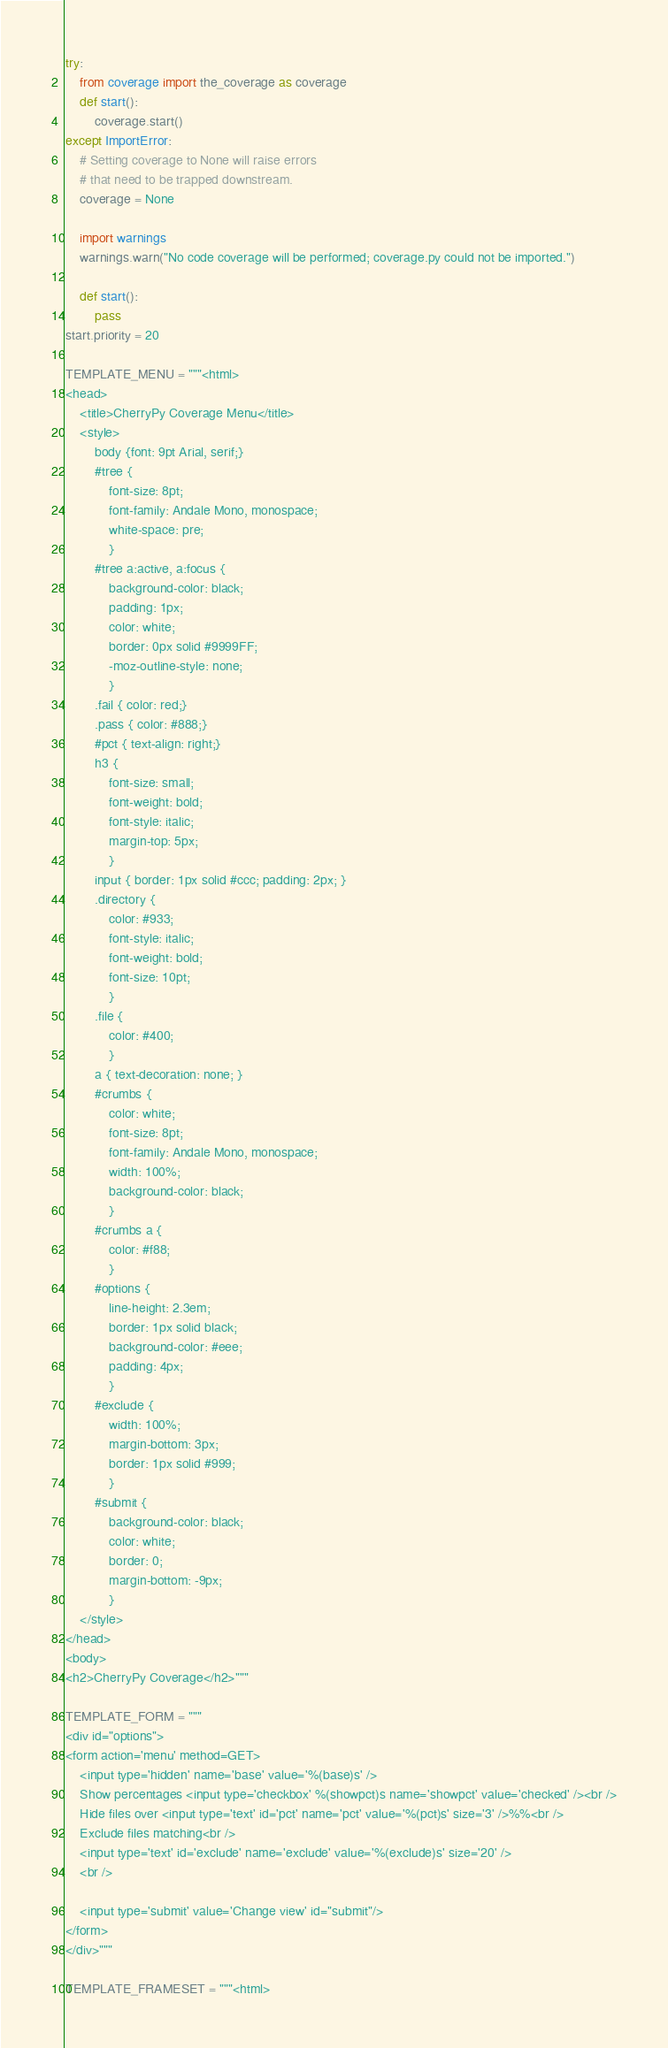Convert code to text. <code><loc_0><loc_0><loc_500><loc_500><_Python_>
try:
    from coverage import the_coverage as coverage
    def start():
        coverage.start()
except ImportError:
    # Setting coverage to None will raise errors
    # that need to be trapped downstream.
    coverage = None
    
    import warnings
    warnings.warn("No code coverage will be performed; coverage.py could not be imported.")
    
    def start():
        pass
start.priority = 20

TEMPLATE_MENU = """<html>
<head>
    <title>CherryPy Coverage Menu</title>
    <style>
        body {font: 9pt Arial, serif;}
        #tree {
            font-size: 8pt;
            font-family: Andale Mono, monospace;
            white-space: pre;
            }
        #tree a:active, a:focus {
            background-color: black;
            padding: 1px;
            color: white;
            border: 0px solid #9999FF;
            -moz-outline-style: none;
            }
        .fail { color: red;}
        .pass { color: #888;}
        #pct { text-align: right;}
        h3 {
            font-size: small;
            font-weight: bold;
            font-style: italic;
            margin-top: 5px; 
            }
        input { border: 1px solid #ccc; padding: 2px; }
        .directory {
            color: #933;
            font-style: italic;
            font-weight: bold;
            font-size: 10pt;
            }
        .file {
            color: #400;
            }
        a { text-decoration: none; }
        #crumbs {
            color: white;
            font-size: 8pt;
            font-family: Andale Mono, monospace;
            width: 100%;
            background-color: black;
            }
        #crumbs a {
            color: #f88;
            }
        #options {
            line-height: 2.3em;
            border: 1px solid black;
            background-color: #eee;
            padding: 4px;
            }
        #exclude {
            width: 100%;
            margin-bottom: 3px;
            border: 1px solid #999;
            }
        #submit {
            background-color: black;
            color: white;
            border: 0;
            margin-bottom: -9px;
            }
    </style>
</head>
<body>
<h2>CherryPy Coverage</h2>"""

TEMPLATE_FORM = """
<div id="options">
<form action='menu' method=GET>
    <input type='hidden' name='base' value='%(base)s' />
    Show percentages <input type='checkbox' %(showpct)s name='showpct' value='checked' /><br />
    Hide files over <input type='text' id='pct' name='pct' value='%(pct)s' size='3' />%%<br />
    Exclude files matching<br />
    <input type='text' id='exclude' name='exclude' value='%(exclude)s' size='20' />
    <br />

    <input type='submit' value='Change view' id="submit"/>
</form>
</div>""" 

TEMPLATE_FRAMESET = """<html></code> 